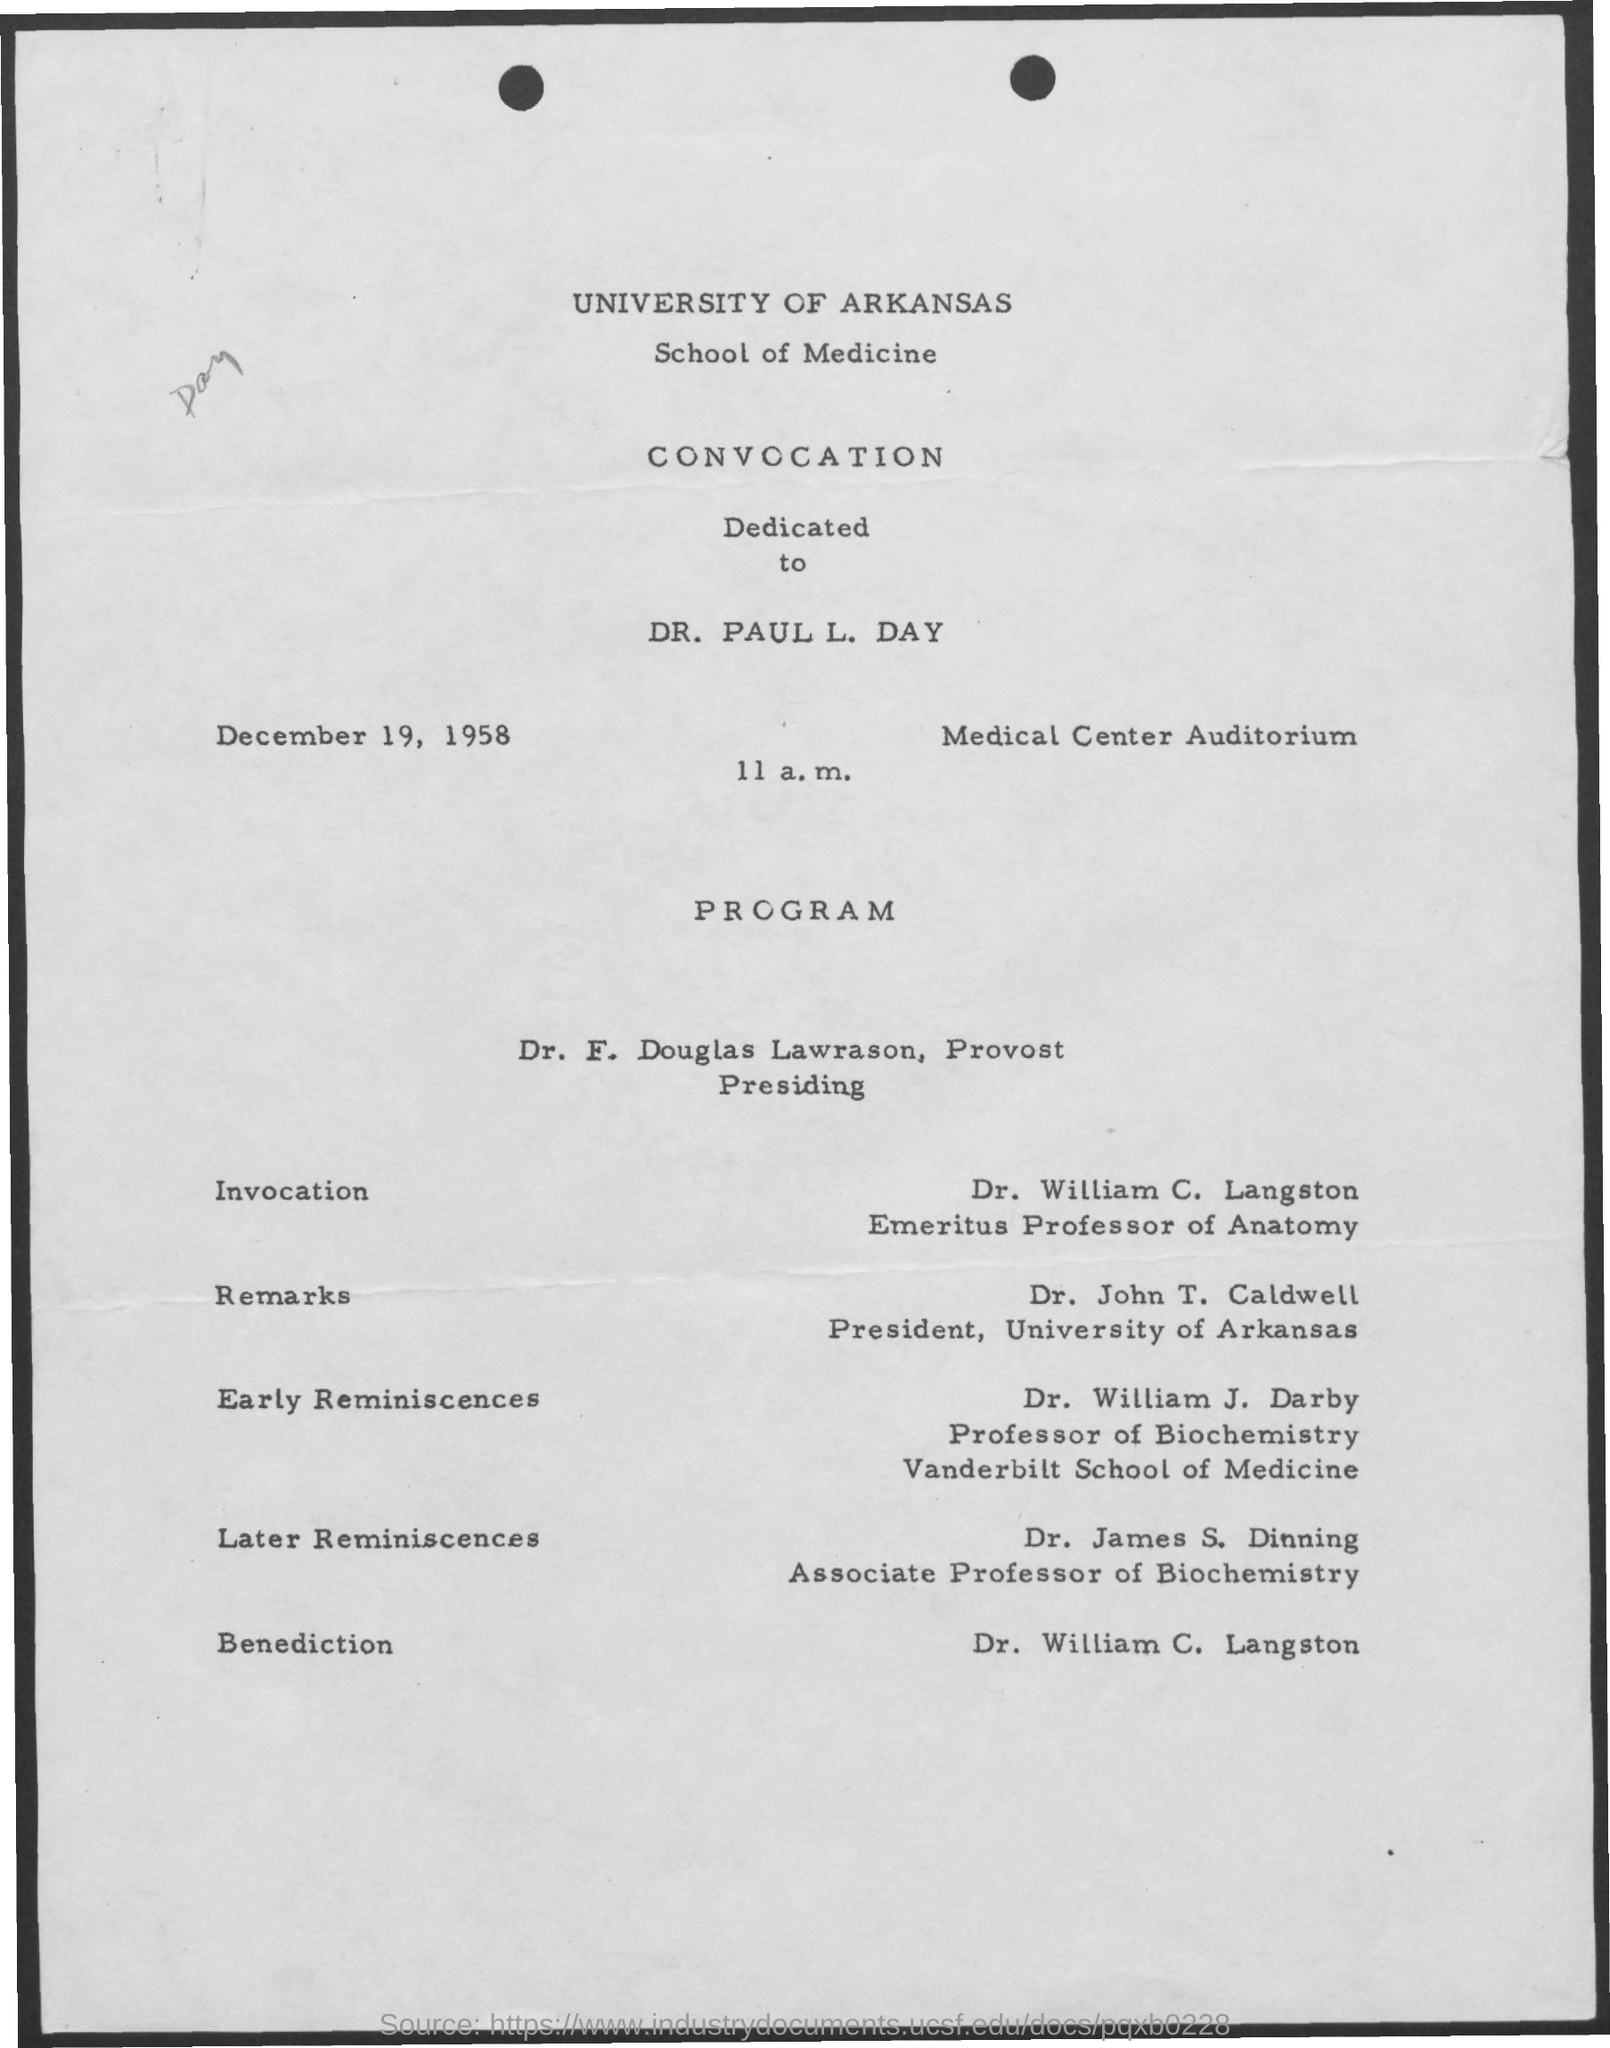Indicate a few pertinent items in this graphic. On December 19 at 11 a.m., the convocation will take place. William C. Langston is an emeritus professor of anatomy who has been designated as such. The document provides information about the date of December 19, 1958. The venue for the event is the Medical Center Auditorium. 